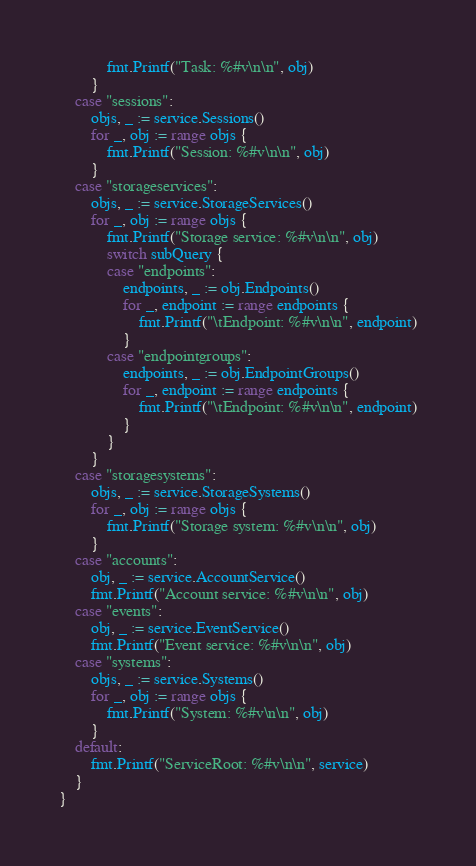<code> <loc_0><loc_0><loc_500><loc_500><_Go_>			fmt.Printf("Task: %#v\n\n", obj)
		}
	case "sessions":
		objs, _ := service.Sessions()
		for _, obj := range objs {
			fmt.Printf("Session: %#v\n\n", obj)
		}
	case "storageservices":
		objs, _ := service.StorageServices()
		for _, obj := range objs {
			fmt.Printf("Storage service: %#v\n\n", obj)
			switch subQuery {
			case "endpoints":
				endpoints, _ := obj.Endpoints()
				for _, endpoint := range endpoints {
					fmt.Printf("\tEndpoint: %#v\n\n", endpoint)
				}
			case "endpointgroups":
				endpoints, _ := obj.EndpointGroups()
				for _, endpoint := range endpoints {
					fmt.Printf("\tEndpoint: %#v\n\n", endpoint)
				}
			}
		}
	case "storagesystems":
		objs, _ := service.StorageSystems()
		for _, obj := range objs {
			fmt.Printf("Storage system: %#v\n\n", obj)
		}
	case "accounts":
		obj, _ := service.AccountService()
		fmt.Printf("Account service: %#v\n\n", obj)
	case "events":
		obj, _ := service.EventService()
		fmt.Printf("Event service: %#v\n\n", obj)
	case "systems":
		objs, _ := service.Systems()
		for _, obj := range objs {
			fmt.Printf("System: %#v\n\n", obj)
		}
	default:
		fmt.Printf("ServiceRoot: %#v\n\n", service)
	}
}
</code> 